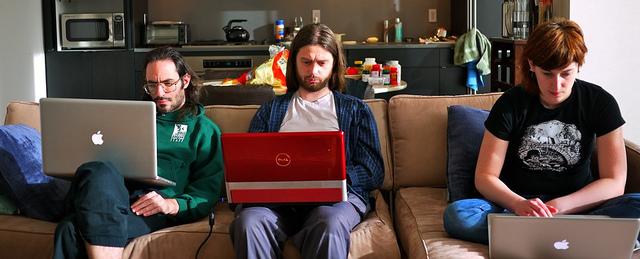Is the laptop red?
Quick response, please. Yes. What brand are the two silver laptops?
Keep it brief. Apple. How many guys are in the photo?
Give a very brief answer. 2. 